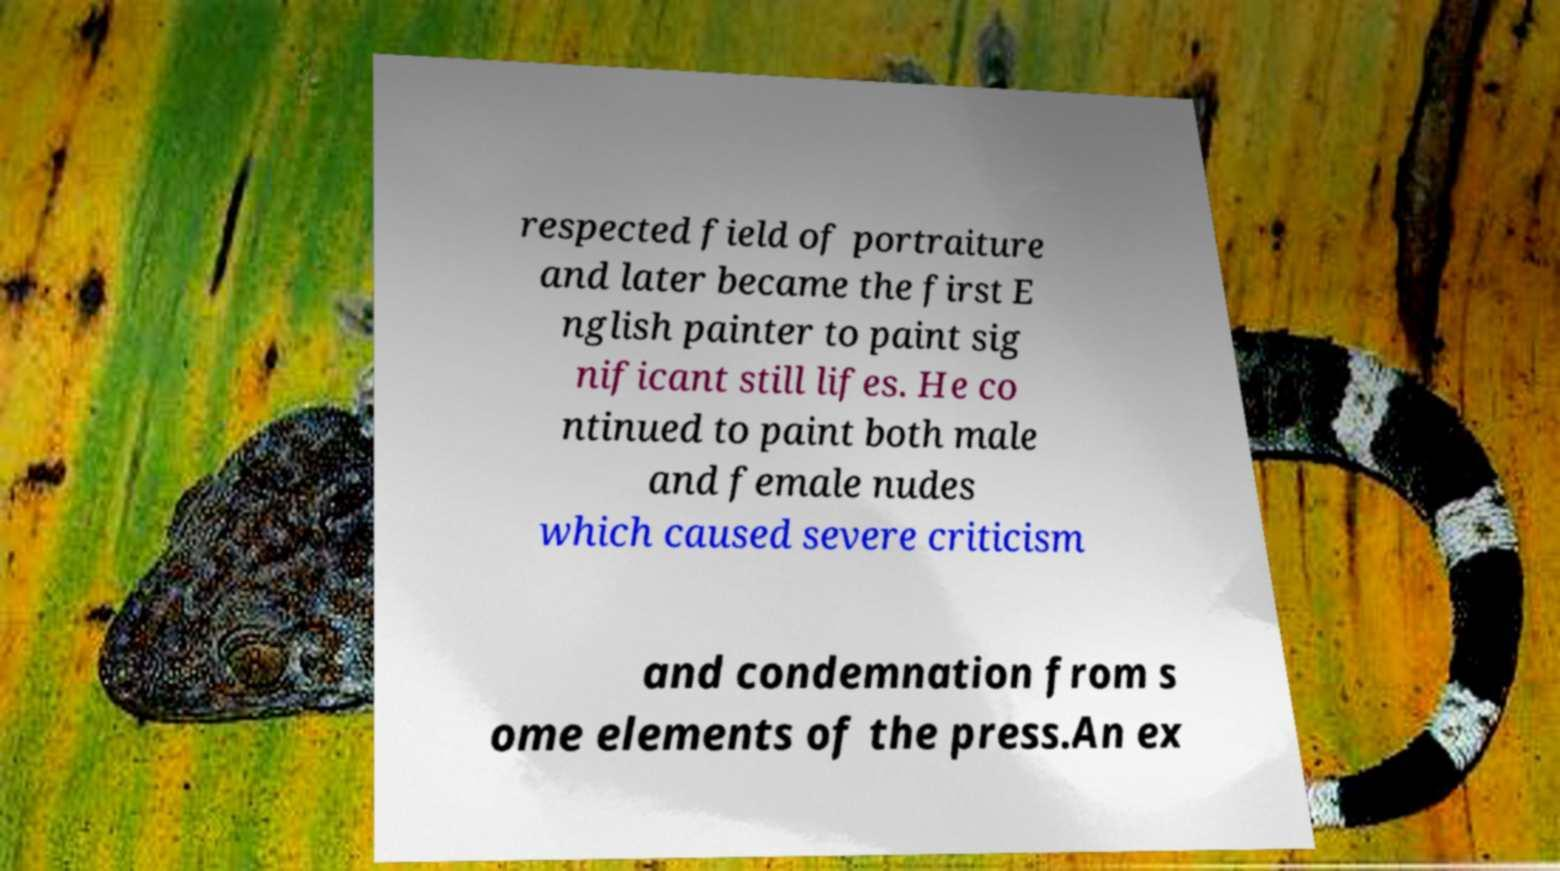Could you assist in decoding the text presented in this image and type it out clearly? respected field of portraiture and later became the first E nglish painter to paint sig nificant still lifes. He co ntinued to paint both male and female nudes which caused severe criticism and condemnation from s ome elements of the press.An ex 